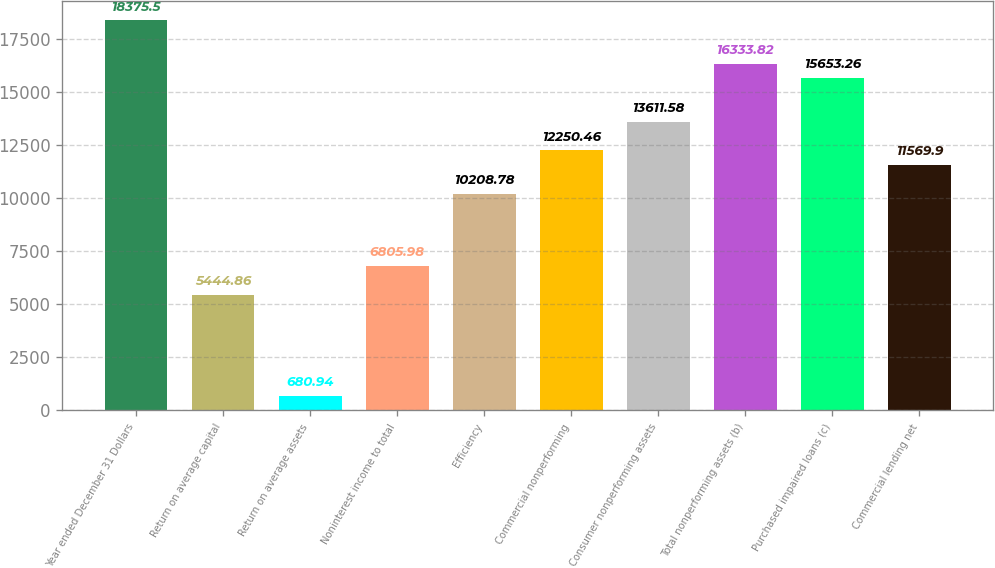Convert chart. <chart><loc_0><loc_0><loc_500><loc_500><bar_chart><fcel>Year ended December 31 Dollars<fcel>Return on average capital<fcel>Return on average assets<fcel>Noninterest income to total<fcel>Efficiency<fcel>Commercial nonperforming<fcel>Consumer nonperforming assets<fcel>Total nonperforming assets (b)<fcel>Purchased impaired loans (c)<fcel>Commercial lending net<nl><fcel>18375.5<fcel>5444.86<fcel>680.94<fcel>6805.98<fcel>10208.8<fcel>12250.5<fcel>13611.6<fcel>16333.8<fcel>15653.3<fcel>11569.9<nl></chart> 